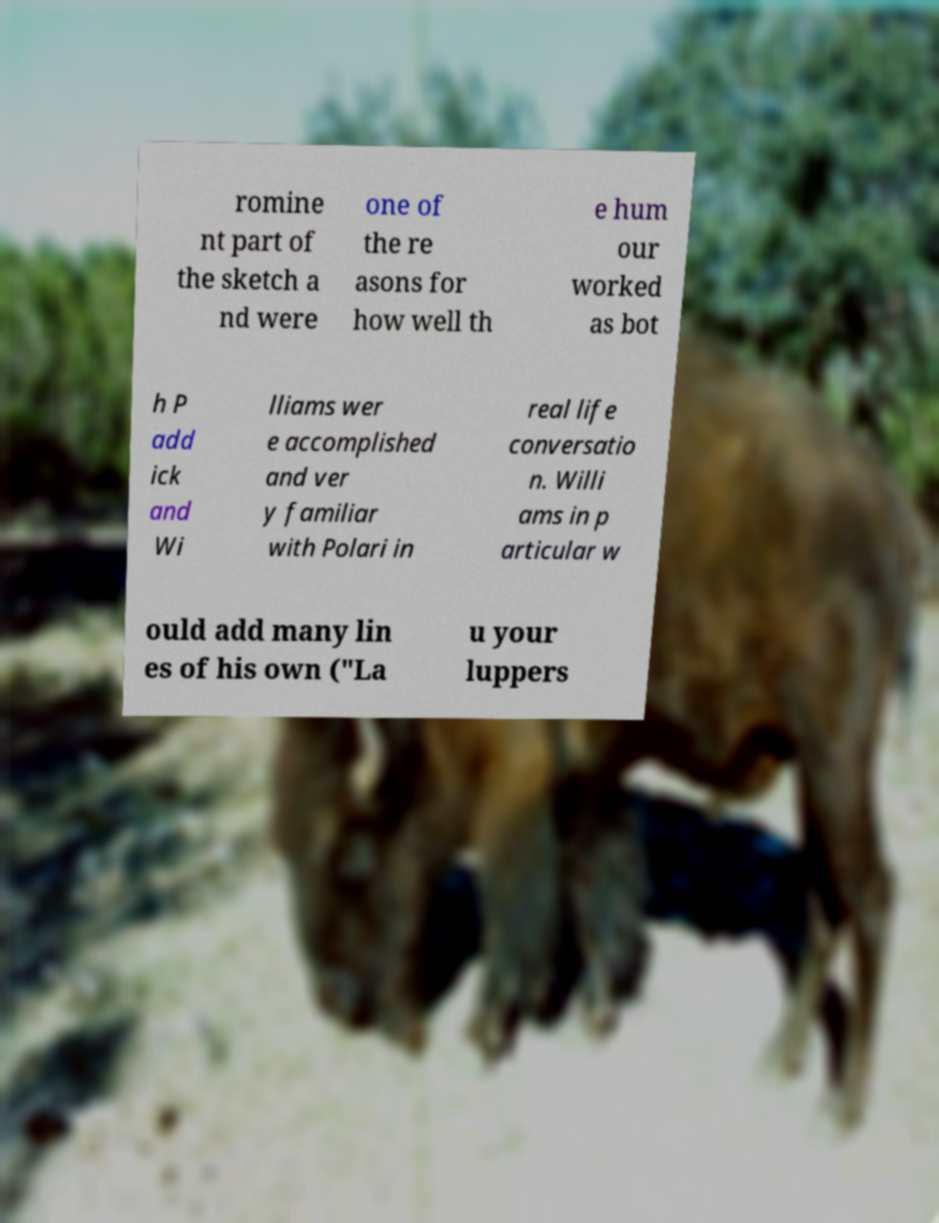Can you read and provide the text displayed in the image?This photo seems to have some interesting text. Can you extract and type it out for me? romine nt part of the sketch a nd were one of the re asons for how well th e hum our worked as bot h P add ick and Wi lliams wer e accomplished and ver y familiar with Polari in real life conversatio n. Willi ams in p articular w ould add many lin es of his own ("La u your luppers 